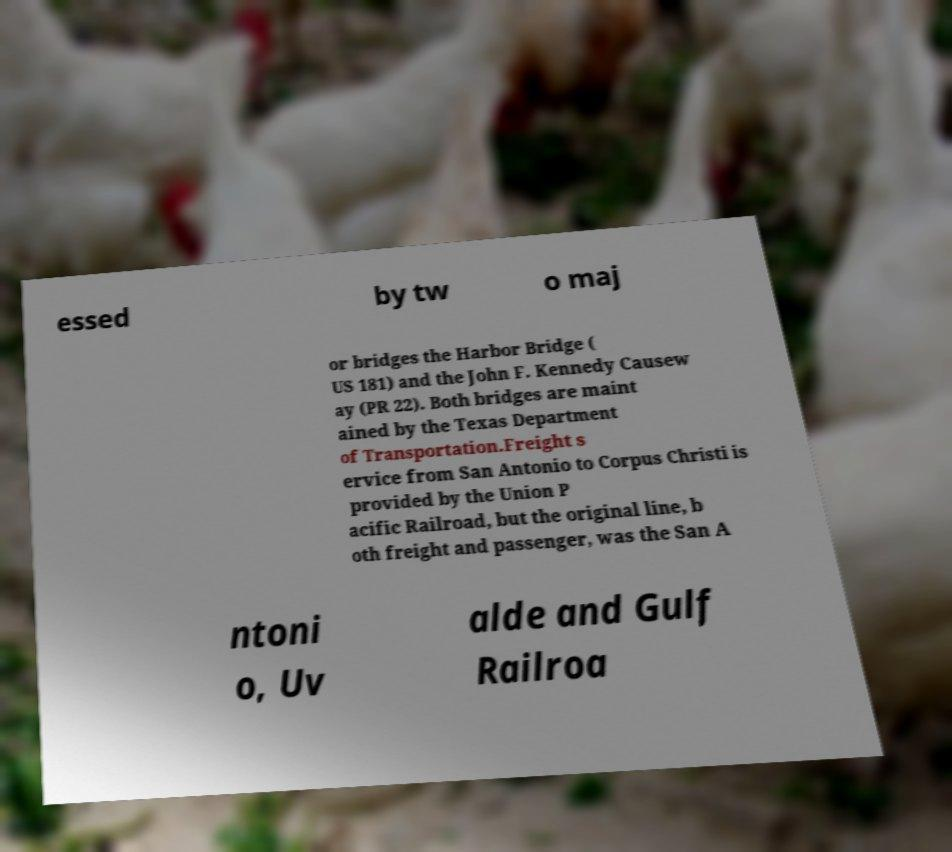For documentation purposes, I need the text within this image transcribed. Could you provide that? essed by tw o maj or bridges the Harbor Bridge ( US 181) and the John F. Kennedy Causew ay (PR 22). Both bridges are maint ained by the Texas Department of Transportation.Freight s ervice from San Antonio to Corpus Christi is provided by the Union P acific Railroad, but the original line, b oth freight and passenger, was the San A ntoni o, Uv alde and Gulf Railroa 